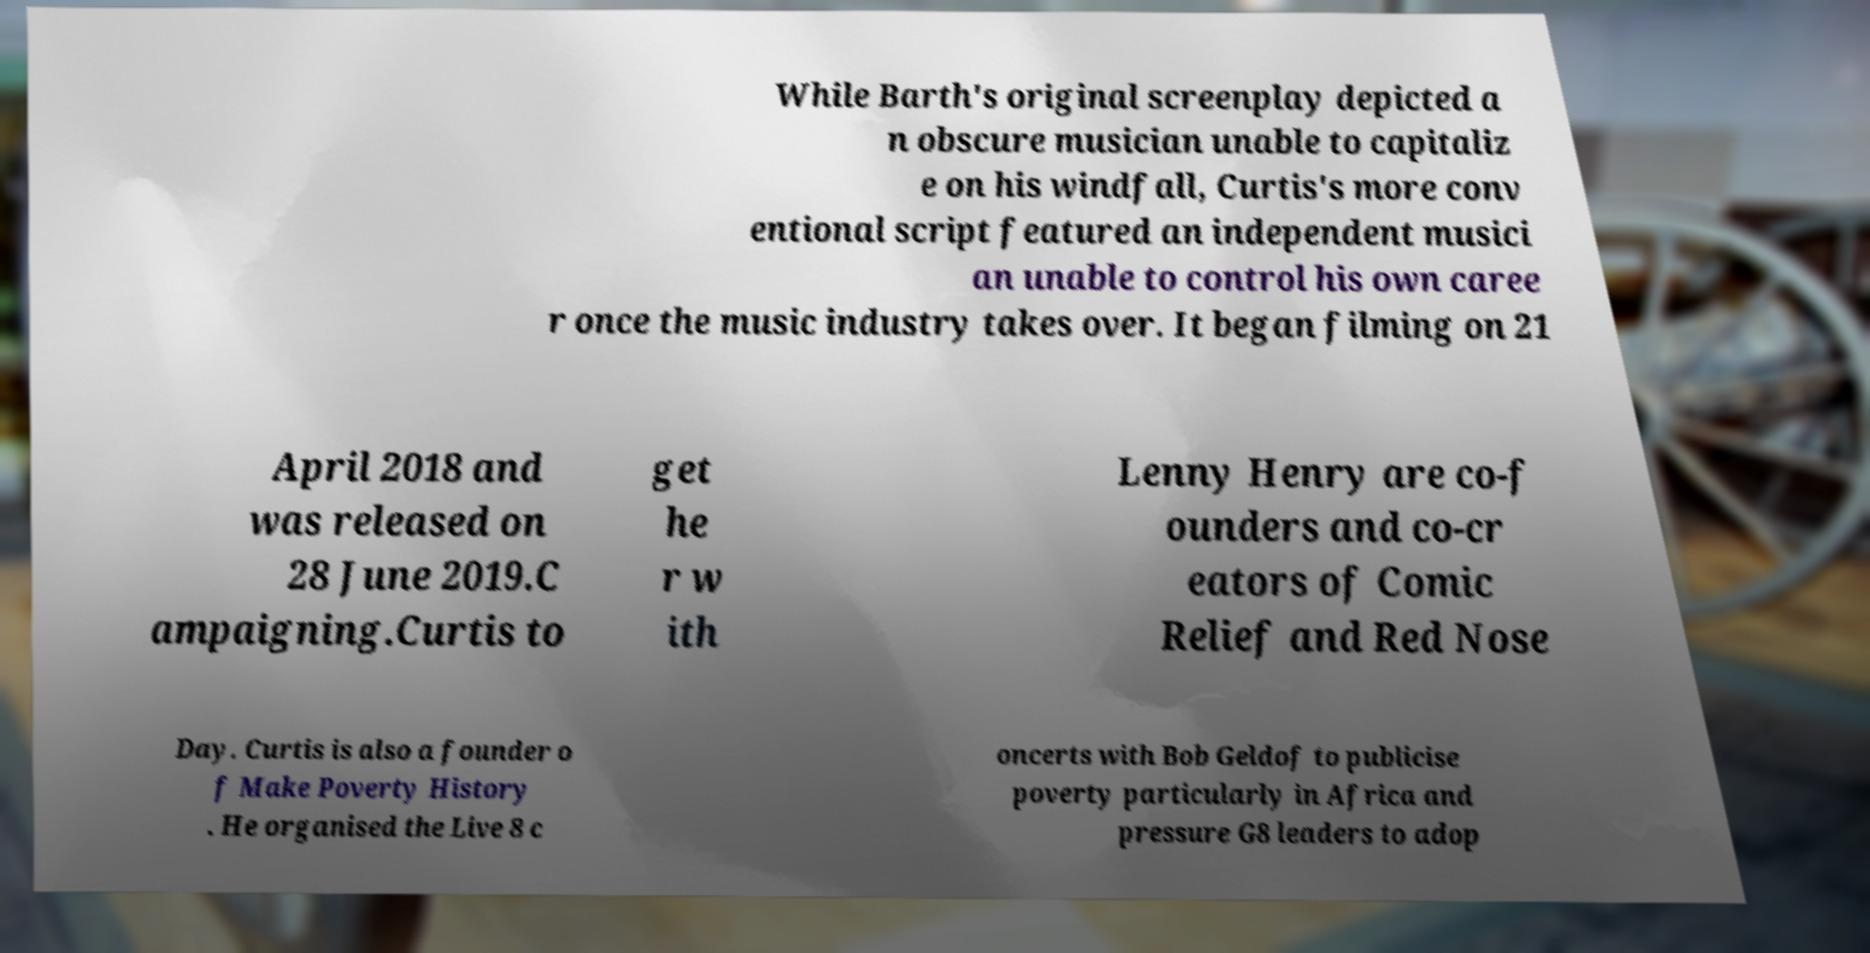Can you accurately transcribe the text from the provided image for me? While Barth's original screenplay depicted a n obscure musician unable to capitaliz e on his windfall, Curtis's more conv entional script featured an independent musici an unable to control his own caree r once the music industry takes over. It began filming on 21 April 2018 and was released on 28 June 2019.C ampaigning.Curtis to get he r w ith Lenny Henry are co-f ounders and co-cr eators of Comic Relief and Red Nose Day. Curtis is also a founder o f Make Poverty History . He organised the Live 8 c oncerts with Bob Geldof to publicise poverty particularly in Africa and pressure G8 leaders to adop 